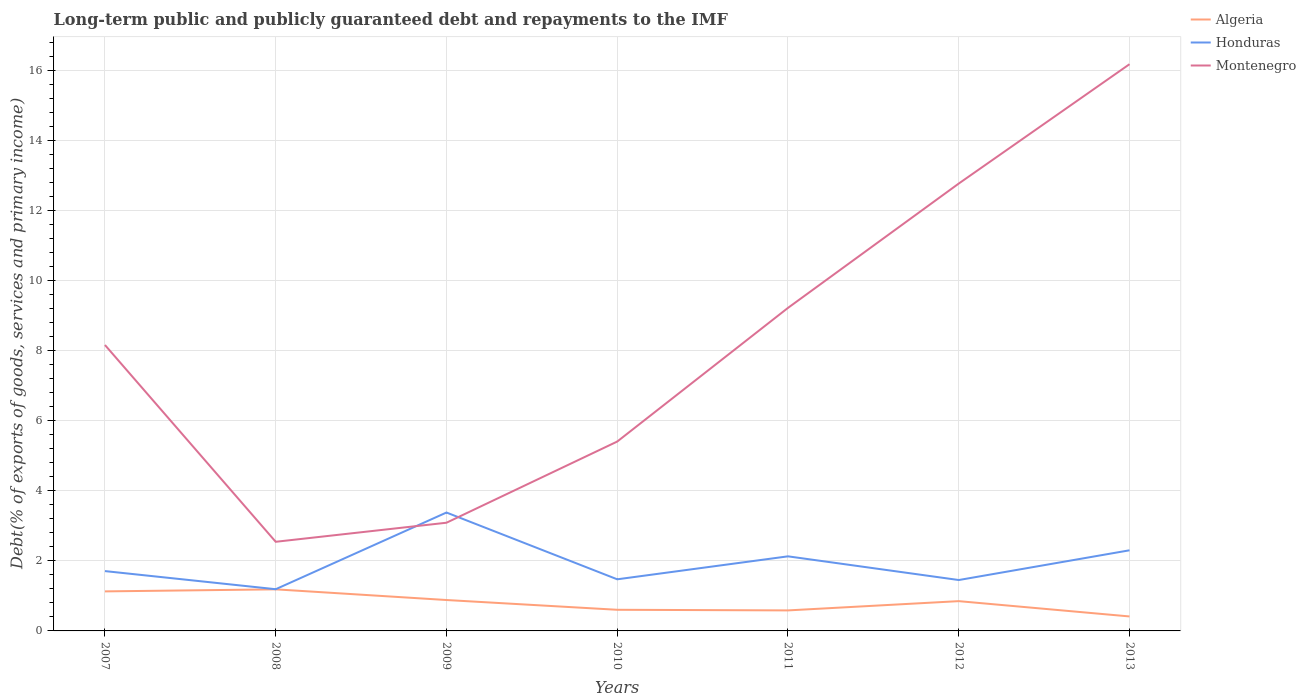Does the line corresponding to Algeria intersect with the line corresponding to Honduras?
Give a very brief answer. No. Across all years, what is the maximum debt and repayments in Honduras?
Make the answer very short. 1.19. What is the total debt and repayments in Honduras in the graph?
Give a very brief answer. -1.67. What is the difference between the highest and the second highest debt and repayments in Honduras?
Your response must be concise. 2.19. What is the difference between the highest and the lowest debt and repayments in Montenegro?
Make the answer very short. 3. Is the debt and repayments in Montenegro strictly greater than the debt and repayments in Honduras over the years?
Provide a succinct answer. No. How many years are there in the graph?
Offer a very short reply. 7. Does the graph contain any zero values?
Provide a short and direct response. No. How many legend labels are there?
Keep it short and to the point. 3. How are the legend labels stacked?
Your response must be concise. Vertical. What is the title of the graph?
Keep it short and to the point. Long-term public and publicly guaranteed debt and repayments to the IMF. Does "Namibia" appear as one of the legend labels in the graph?
Your answer should be very brief. No. What is the label or title of the Y-axis?
Provide a short and direct response. Debt(% of exports of goods, services and primary income). What is the Debt(% of exports of goods, services and primary income) in Algeria in 2007?
Your answer should be very brief. 1.13. What is the Debt(% of exports of goods, services and primary income) in Honduras in 2007?
Your answer should be very brief. 1.71. What is the Debt(% of exports of goods, services and primary income) in Montenegro in 2007?
Your answer should be compact. 8.17. What is the Debt(% of exports of goods, services and primary income) in Algeria in 2008?
Offer a very short reply. 1.19. What is the Debt(% of exports of goods, services and primary income) of Honduras in 2008?
Provide a succinct answer. 1.19. What is the Debt(% of exports of goods, services and primary income) in Montenegro in 2008?
Your answer should be compact. 2.55. What is the Debt(% of exports of goods, services and primary income) of Algeria in 2009?
Your response must be concise. 0.88. What is the Debt(% of exports of goods, services and primary income) of Honduras in 2009?
Your answer should be very brief. 3.38. What is the Debt(% of exports of goods, services and primary income) of Montenegro in 2009?
Keep it short and to the point. 3.09. What is the Debt(% of exports of goods, services and primary income) of Algeria in 2010?
Provide a succinct answer. 0.6. What is the Debt(% of exports of goods, services and primary income) of Honduras in 2010?
Give a very brief answer. 1.47. What is the Debt(% of exports of goods, services and primary income) of Montenegro in 2010?
Make the answer very short. 5.41. What is the Debt(% of exports of goods, services and primary income) of Algeria in 2011?
Provide a succinct answer. 0.59. What is the Debt(% of exports of goods, services and primary income) in Honduras in 2011?
Provide a short and direct response. 2.13. What is the Debt(% of exports of goods, services and primary income) of Montenegro in 2011?
Ensure brevity in your answer.  9.23. What is the Debt(% of exports of goods, services and primary income) of Algeria in 2012?
Make the answer very short. 0.85. What is the Debt(% of exports of goods, services and primary income) in Honduras in 2012?
Your answer should be compact. 1.45. What is the Debt(% of exports of goods, services and primary income) of Montenegro in 2012?
Provide a succinct answer. 12.78. What is the Debt(% of exports of goods, services and primary income) in Algeria in 2013?
Your answer should be very brief. 0.41. What is the Debt(% of exports of goods, services and primary income) in Honduras in 2013?
Make the answer very short. 2.3. What is the Debt(% of exports of goods, services and primary income) of Montenegro in 2013?
Provide a succinct answer. 16.19. Across all years, what is the maximum Debt(% of exports of goods, services and primary income) in Algeria?
Keep it short and to the point. 1.19. Across all years, what is the maximum Debt(% of exports of goods, services and primary income) of Honduras?
Make the answer very short. 3.38. Across all years, what is the maximum Debt(% of exports of goods, services and primary income) in Montenegro?
Your response must be concise. 16.19. Across all years, what is the minimum Debt(% of exports of goods, services and primary income) in Algeria?
Your answer should be very brief. 0.41. Across all years, what is the minimum Debt(% of exports of goods, services and primary income) of Honduras?
Ensure brevity in your answer.  1.19. Across all years, what is the minimum Debt(% of exports of goods, services and primary income) of Montenegro?
Offer a very short reply. 2.55. What is the total Debt(% of exports of goods, services and primary income) in Algeria in the graph?
Ensure brevity in your answer.  5.66. What is the total Debt(% of exports of goods, services and primary income) in Honduras in the graph?
Offer a terse response. 13.65. What is the total Debt(% of exports of goods, services and primary income) in Montenegro in the graph?
Offer a very short reply. 57.42. What is the difference between the Debt(% of exports of goods, services and primary income) of Algeria in 2007 and that in 2008?
Make the answer very short. -0.06. What is the difference between the Debt(% of exports of goods, services and primary income) in Honduras in 2007 and that in 2008?
Offer a terse response. 0.52. What is the difference between the Debt(% of exports of goods, services and primary income) of Montenegro in 2007 and that in 2008?
Provide a succinct answer. 5.62. What is the difference between the Debt(% of exports of goods, services and primary income) of Algeria in 2007 and that in 2009?
Offer a terse response. 0.25. What is the difference between the Debt(% of exports of goods, services and primary income) of Honduras in 2007 and that in 2009?
Provide a succinct answer. -1.67. What is the difference between the Debt(% of exports of goods, services and primary income) of Montenegro in 2007 and that in 2009?
Your response must be concise. 5.08. What is the difference between the Debt(% of exports of goods, services and primary income) of Algeria in 2007 and that in 2010?
Your response must be concise. 0.53. What is the difference between the Debt(% of exports of goods, services and primary income) of Honduras in 2007 and that in 2010?
Your response must be concise. 0.23. What is the difference between the Debt(% of exports of goods, services and primary income) of Montenegro in 2007 and that in 2010?
Give a very brief answer. 2.76. What is the difference between the Debt(% of exports of goods, services and primary income) of Algeria in 2007 and that in 2011?
Give a very brief answer. 0.54. What is the difference between the Debt(% of exports of goods, services and primary income) of Honduras in 2007 and that in 2011?
Make the answer very short. -0.42. What is the difference between the Debt(% of exports of goods, services and primary income) of Montenegro in 2007 and that in 2011?
Offer a very short reply. -1.06. What is the difference between the Debt(% of exports of goods, services and primary income) in Algeria in 2007 and that in 2012?
Offer a very short reply. 0.28. What is the difference between the Debt(% of exports of goods, services and primary income) of Honduras in 2007 and that in 2012?
Make the answer very short. 0.26. What is the difference between the Debt(% of exports of goods, services and primary income) in Montenegro in 2007 and that in 2012?
Your response must be concise. -4.61. What is the difference between the Debt(% of exports of goods, services and primary income) in Algeria in 2007 and that in 2013?
Offer a terse response. 0.72. What is the difference between the Debt(% of exports of goods, services and primary income) in Honduras in 2007 and that in 2013?
Your answer should be compact. -0.59. What is the difference between the Debt(% of exports of goods, services and primary income) of Montenegro in 2007 and that in 2013?
Your response must be concise. -8.02. What is the difference between the Debt(% of exports of goods, services and primary income) in Algeria in 2008 and that in 2009?
Provide a short and direct response. 0.3. What is the difference between the Debt(% of exports of goods, services and primary income) in Honduras in 2008 and that in 2009?
Ensure brevity in your answer.  -2.19. What is the difference between the Debt(% of exports of goods, services and primary income) in Montenegro in 2008 and that in 2009?
Your answer should be compact. -0.54. What is the difference between the Debt(% of exports of goods, services and primary income) in Algeria in 2008 and that in 2010?
Provide a short and direct response. 0.58. What is the difference between the Debt(% of exports of goods, services and primary income) of Honduras in 2008 and that in 2010?
Your answer should be very brief. -0.28. What is the difference between the Debt(% of exports of goods, services and primary income) in Montenegro in 2008 and that in 2010?
Your answer should be compact. -2.86. What is the difference between the Debt(% of exports of goods, services and primary income) of Algeria in 2008 and that in 2011?
Make the answer very short. 0.6. What is the difference between the Debt(% of exports of goods, services and primary income) in Honduras in 2008 and that in 2011?
Provide a short and direct response. -0.94. What is the difference between the Debt(% of exports of goods, services and primary income) in Montenegro in 2008 and that in 2011?
Give a very brief answer. -6.68. What is the difference between the Debt(% of exports of goods, services and primary income) in Algeria in 2008 and that in 2012?
Keep it short and to the point. 0.34. What is the difference between the Debt(% of exports of goods, services and primary income) of Honduras in 2008 and that in 2012?
Your response must be concise. -0.26. What is the difference between the Debt(% of exports of goods, services and primary income) of Montenegro in 2008 and that in 2012?
Keep it short and to the point. -10.24. What is the difference between the Debt(% of exports of goods, services and primary income) in Algeria in 2008 and that in 2013?
Give a very brief answer. 0.77. What is the difference between the Debt(% of exports of goods, services and primary income) in Honduras in 2008 and that in 2013?
Ensure brevity in your answer.  -1.11. What is the difference between the Debt(% of exports of goods, services and primary income) of Montenegro in 2008 and that in 2013?
Offer a terse response. -13.65. What is the difference between the Debt(% of exports of goods, services and primary income) in Algeria in 2009 and that in 2010?
Your answer should be very brief. 0.28. What is the difference between the Debt(% of exports of goods, services and primary income) in Honduras in 2009 and that in 2010?
Your answer should be compact. 1.91. What is the difference between the Debt(% of exports of goods, services and primary income) in Montenegro in 2009 and that in 2010?
Your response must be concise. -2.32. What is the difference between the Debt(% of exports of goods, services and primary income) in Algeria in 2009 and that in 2011?
Offer a very short reply. 0.3. What is the difference between the Debt(% of exports of goods, services and primary income) in Honduras in 2009 and that in 2011?
Offer a very short reply. 1.25. What is the difference between the Debt(% of exports of goods, services and primary income) in Montenegro in 2009 and that in 2011?
Your answer should be very brief. -6.14. What is the difference between the Debt(% of exports of goods, services and primary income) of Algeria in 2009 and that in 2012?
Your answer should be very brief. 0.03. What is the difference between the Debt(% of exports of goods, services and primary income) in Honduras in 2009 and that in 2012?
Ensure brevity in your answer.  1.93. What is the difference between the Debt(% of exports of goods, services and primary income) of Montenegro in 2009 and that in 2012?
Provide a succinct answer. -9.69. What is the difference between the Debt(% of exports of goods, services and primary income) in Algeria in 2009 and that in 2013?
Give a very brief answer. 0.47. What is the difference between the Debt(% of exports of goods, services and primary income) in Honduras in 2009 and that in 2013?
Make the answer very short. 1.08. What is the difference between the Debt(% of exports of goods, services and primary income) in Montenegro in 2009 and that in 2013?
Keep it short and to the point. -13.1. What is the difference between the Debt(% of exports of goods, services and primary income) of Algeria in 2010 and that in 2011?
Give a very brief answer. 0.02. What is the difference between the Debt(% of exports of goods, services and primary income) in Honduras in 2010 and that in 2011?
Keep it short and to the point. -0.66. What is the difference between the Debt(% of exports of goods, services and primary income) in Montenegro in 2010 and that in 2011?
Offer a very short reply. -3.82. What is the difference between the Debt(% of exports of goods, services and primary income) in Algeria in 2010 and that in 2012?
Keep it short and to the point. -0.25. What is the difference between the Debt(% of exports of goods, services and primary income) in Honduras in 2010 and that in 2012?
Ensure brevity in your answer.  0.02. What is the difference between the Debt(% of exports of goods, services and primary income) of Montenegro in 2010 and that in 2012?
Your answer should be very brief. -7.37. What is the difference between the Debt(% of exports of goods, services and primary income) of Algeria in 2010 and that in 2013?
Give a very brief answer. 0.19. What is the difference between the Debt(% of exports of goods, services and primary income) in Honduras in 2010 and that in 2013?
Ensure brevity in your answer.  -0.83. What is the difference between the Debt(% of exports of goods, services and primary income) of Montenegro in 2010 and that in 2013?
Offer a very short reply. -10.78. What is the difference between the Debt(% of exports of goods, services and primary income) in Algeria in 2011 and that in 2012?
Offer a very short reply. -0.26. What is the difference between the Debt(% of exports of goods, services and primary income) in Honduras in 2011 and that in 2012?
Offer a terse response. 0.68. What is the difference between the Debt(% of exports of goods, services and primary income) in Montenegro in 2011 and that in 2012?
Your answer should be very brief. -3.55. What is the difference between the Debt(% of exports of goods, services and primary income) in Algeria in 2011 and that in 2013?
Provide a succinct answer. 0.17. What is the difference between the Debt(% of exports of goods, services and primary income) in Honduras in 2011 and that in 2013?
Your response must be concise. -0.17. What is the difference between the Debt(% of exports of goods, services and primary income) in Montenegro in 2011 and that in 2013?
Provide a succinct answer. -6.96. What is the difference between the Debt(% of exports of goods, services and primary income) in Algeria in 2012 and that in 2013?
Provide a succinct answer. 0.44. What is the difference between the Debt(% of exports of goods, services and primary income) in Honduras in 2012 and that in 2013?
Offer a very short reply. -0.85. What is the difference between the Debt(% of exports of goods, services and primary income) in Montenegro in 2012 and that in 2013?
Your answer should be very brief. -3.41. What is the difference between the Debt(% of exports of goods, services and primary income) in Algeria in 2007 and the Debt(% of exports of goods, services and primary income) in Honduras in 2008?
Make the answer very short. -0.06. What is the difference between the Debt(% of exports of goods, services and primary income) in Algeria in 2007 and the Debt(% of exports of goods, services and primary income) in Montenegro in 2008?
Make the answer very short. -1.42. What is the difference between the Debt(% of exports of goods, services and primary income) in Honduras in 2007 and the Debt(% of exports of goods, services and primary income) in Montenegro in 2008?
Keep it short and to the point. -0.84. What is the difference between the Debt(% of exports of goods, services and primary income) of Algeria in 2007 and the Debt(% of exports of goods, services and primary income) of Honduras in 2009?
Provide a succinct answer. -2.25. What is the difference between the Debt(% of exports of goods, services and primary income) in Algeria in 2007 and the Debt(% of exports of goods, services and primary income) in Montenegro in 2009?
Provide a succinct answer. -1.96. What is the difference between the Debt(% of exports of goods, services and primary income) in Honduras in 2007 and the Debt(% of exports of goods, services and primary income) in Montenegro in 2009?
Your response must be concise. -1.38. What is the difference between the Debt(% of exports of goods, services and primary income) in Algeria in 2007 and the Debt(% of exports of goods, services and primary income) in Honduras in 2010?
Your response must be concise. -0.35. What is the difference between the Debt(% of exports of goods, services and primary income) of Algeria in 2007 and the Debt(% of exports of goods, services and primary income) of Montenegro in 2010?
Your answer should be very brief. -4.28. What is the difference between the Debt(% of exports of goods, services and primary income) in Honduras in 2007 and the Debt(% of exports of goods, services and primary income) in Montenegro in 2010?
Provide a short and direct response. -3.7. What is the difference between the Debt(% of exports of goods, services and primary income) in Algeria in 2007 and the Debt(% of exports of goods, services and primary income) in Honduras in 2011?
Keep it short and to the point. -1. What is the difference between the Debt(% of exports of goods, services and primary income) of Algeria in 2007 and the Debt(% of exports of goods, services and primary income) of Montenegro in 2011?
Provide a succinct answer. -8.1. What is the difference between the Debt(% of exports of goods, services and primary income) in Honduras in 2007 and the Debt(% of exports of goods, services and primary income) in Montenegro in 2011?
Offer a very short reply. -7.52. What is the difference between the Debt(% of exports of goods, services and primary income) in Algeria in 2007 and the Debt(% of exports of goods, services and primary income) in Honduras in 2012?
Provide a succinct answer. -0.32. What is the difference between the Debt(% of exports of goods, services and primary income) in Algeria in 2007 and the Debt(% of exports of goods, services and primary income) in Montenegro in 2012?
Keep it short and to the point. -11.65. What is the difference between the Debt(% of exports of goods, services and primary income) of Honduras in 2007 and the Debt(% of exports of goods, services and primary income) of Montenegro in 2012?
Provide a succinct answer. -11.07. What is the difference between the Debt(% of exports of goods, services and primary income) in Algeria in 2007 and the Debt(% of exports of goods, services and primary income) in Honduras in 2013?
Give a very brief answer. -1.17. What is the difference between the Debt(% of exports of goods, services and primary income) of Algeria in 2007 and the Debt(% of exports of goods, services and primary income) of Montenegro in 2013?
Your answer should be very brief. -15.06. What is the difference between the Debt(% of exports of goods, services and primary income) in Honduras in 2007 and the Debt(% of exports of goods, services and primary income) in Montenegro in 2013?
Your response must be concise. -14.48. What is the difference between the Debt(% of exports of goods, services and primary income) of Algeria in 2008 and the Debt(% of exports of goods, services and primary income) of Honduras in 2009?
Your response must be concise. -2.19. What is the difference between the Debt(% of exports of goods, services and primary income) in Algeria in 2008 and the Debt(% of exports of goods, services and primary income) in Montenegro in 2009?
Offer a terse response. -1.9. What is the difference between the Debt(% of exports of goods, services and primary income) of Honduras in 2008 and the Debt(% of exports of goods, services and primary income) of Montenegro in 2009?
Your response must be concise. -1.9. What is the difference between the Debt(% of exports of goods, services and primary income) in Algeria in 2008 and the Debt(% of exports of goods, services and primary income) in Honduras in 2010?
Offer a very short reply. -0.29. What is the difference between the Debt(% of exports of goods, services and primary income) in Algeria in 2008 and the Debt(% of exports of goods, services and primary income) in Montenegro in 2010?
Your response must be concise. -4.22. What is the difference between the Debt(% of exports of goods, services and primary income) of Honduras in 2008 and the Debt(% of exports of goods, services and primary income) of Montenegro in 2010?
Give a very brief answer. -4.22. What is the difference between the Debt(% of exports of goods, services and primary income) in Algeria in 2008 and the Debt(% of exports of goods, services and primary income) in Honduras in 2011?
Make the answer very short. -0.94. What is the difference between the Debt(% of exports of goods, services and primary income) of Algeria in 2008 and the Debt(% of exports of goods, services and primary income) of Montenegro in 2011?
Your response must be concise. -8.04. What is the difference between the Debt(% of exports of goods, services and primary income) in Honduras in 2008 and the Debt(% of exports of goods, services and primary income) in Montenegro in 2011?
Keep it short and to the point. -8.04. What is the difference between the Debt(% of exports of goods, services and primary income) of Algeria in 2008 and the Debt(% of exports of goods, services and primary income) of Honduras in 2012?
Provide a short and direct response. -0.27. What is the difference between the Debt(% of exports of goods, services and primary income) of Algeria in 2008 and the Debt(% of exports of goods, services and primary income) of Montenegro in 2012?
Your answer should be compact. -11.59. What is the difference between the Debt(% of exports of goods, services and primary income) in Honduras in 2008 and the Debt(% of exports of goods, services and primary income) in Montenegro in 2012?
Give a very brief answer. -11.59. What is the difference between the Debt(% of exports of goods, services and primary income) of Algeria in 2008 and the Debt(% of exports of goods, services and primary income) of Honduras in 2013?
Your answer should be compact. -1.12. What is the difference between the Debt(% of exports of goods, services and primary income) of Algeria in 2008 and the Debt(% of exports of goods, services and primary income) of Montenegro in 2013?
Keep it short and to the point. -15. What is the difference between the Debt(% of exports of goods, services and primary income) in Honduras in 2008 and the Debt(% of exports of goods, services and primary income) in Montenegro in 2013?
Offer a terse response. -15. What is the difference between the Debt(% of exports of goods, services and primary income) in Algeria in 2009 and the Debt(% of exports of goods, services and primary income) in Honduras in 2010?
Keep it short and to the point. -0.59. What is the difference between the Debt(% of exports of goods, services and primary income) of Algeria in 2009 and the Debt(% of exports of goods, services and primary income) of Montenegro in 2010?
Provide a short and direct response. -4.53. What is the difference between the Debt(% of exports of goods, services and primary income) in Honduras in 2009 and the Debt(% of exports of goods, services and primary income) in Montenegro in 2010?
Your response must be concise. -2.03. What is the difference between the Debt(% of exports of goods, services and primary income) in Algeria in 2009 and the Debt(% of exports of goods, services and primary income) in Honduras in 2011?
Your answer should be compact. -1.25. What is the difference between the Debt(% of exports of goods, services and primary income) in Algeria in 2009 and the Debt(% of exports of goods, services and primary income) in Montenegro in 2011?
Offer a terse response. -8.35. What is the difference between the Debt(% of exports of goods, services and primary income) of Honduras in 2009 and the Debt(% of exports of goods, services and primary income) of Montenegro in 2011?
Provide a succinct answer. -5.85. What is the difference between the Debt(% of exports of goods, services and primary income) in Algeria in 2009 and the Debt(% of exports of goods, services and primary income) in Honduras in 2012?
Offer a terse response. -0.57. What is the difference between the Debt(% of exports of goods, services and primary income) in Algeria in 2009 and the Debt(% of exports of goods, services and primary income) in Montenegro in 2012?
Ensure brevity in your answer.  -11.9. What is the difference between the Debt(% of exports of goods, services and primary income) in Honduras in 2009 and the Debt(% of exports of goods, services and primary income) in Montenegro in 2012?
Your answer should be compact. -9.4. What is the difference between the Debt(% of exports of goods, services and primary income) in Algeria in 2009 and the Debt(% of exports of goods, services and primary income) in Honduras in 2013?
Offer a very short reply. -1.42. What is the difference between the Debt(% of exports of goods, services and primary income) in Algeria in 2009 and the Debt(% of exports of goods, services and primary income) in Montenegro in 2013?
Make the answer very short. -15.31. What is the difference between the Debt(% of exports of goods, services and primary income) in Honduras in 2009 and the Debt(% of exports of goods, services and primary income) in Montenegro in 2013?
Your response must be concise. -12.81. What is the difference between the Debt(% of exports of goods, services and primary income) of Algeria in 2010 and the Debt(% of exports of goods, services and primary income) of Honduras in 2011?
Provide a short and direct response. -1.53. What is the difference between the Debt(% of exports of goods, services and primary income) in Algeria in 2010 and the Debt(% of exports of goods, services and primary income) in Montenegro in 2011?
Keep it short and to the point. -8.63. What is the difference between the Debt(% of exports of goods, services and primary income) of Honduras in 2010 and the Debt(% of exports of goods, services and primary income) of Montenegro in 2011?
Your response must be concise. -7.75. What is the difference between the Debt(% of exports of goods, services and primary income) of Algeria in 2010 and the Debt(% of exports of goods, services and primary income) of Honduras in 2012?
Offer a terse response. -0.85. What is the difference between the Debt(% of exports of goods, services and primary income) in Algeria in 2010 and the Debt(% of exports of goods, services and primary income) in Montenegro in 2012?
Offer a very short reply. -12.18. What is the difference between the Debt(% of exports of goods, services and primary income) of Honduras in 2010 and the Debt(% of exports of goods, services and primary income) of Montenegro in 2012?
Your answer should be very brief. -11.31. What is the difference between the Debt(% of exports of goods, services and primary income) in Algeria in 2010 and the Debt(% of exports of goods, services and primary income) in Honduras in 2013?
Keep it short and to the point. -1.7. What is the difference between the Debt(% of exports of goods, services and primary income) in Algeria in 2010 and the Debt(% of exports of goods, services and primary income) in Montenegro in 2013?
Offer a terse response. -15.59. What is the difference between the Debt(% of exports of goods, services and primary income) of Honduras in 2010 and the Debt(% of exports of goods, services and primary income) of Montenegro in 2013?
Provide a short and direct response. -14.72. What is the difference between the Debt(% of exports of goods, services and primary income) of Algeria in 2011 and the Debt(% of exports of goods, services and primary income) of Honduras in 2012?
Your response must be concise. -0.87. What is the difference between the Debt(% of exports of goods, services and primary income) of Algeria in 2011 and the Debt(% of exports of goods, services and primary income) of Montenegro in 2012?
Offer a terse response. -12.2. What is the difference between the Debt(% of exports of goods, services and primary income) in Honduras in 2011 and the Debt(% of exports of goods, services and primary income) in Montenegro in 2012?
Provide a succinct answer. -10.65. What is the difference between the Debt(% of exports of goods, services and primary income) in Algeria in 2011 and the Debt(% of exports of goods, services and primary income) in Honduras in 2013?
Your answer should be very brief. -1.72. What is the difference between the Debt(% of exports of goods, services and primary income) in Algeria in 2011 and the Debt(% of exports of goods, services and primary income) in Montenegro in 2013?
Provide a short and direct response. -15.61. What is the difference between the Debt(% of exports of goods, services and primary income) in Honduras in 2011 and the Debt(% of exports of goods, services and primary income) in Montenegro in 2013?
Your answer should be very brief. -14.06. What is the difference between the Debt(% of exports of goods, services and primary income) in Algeria in 2012 and the Debt(% of exports of goods, services and primary income) in Honduras in 2013?
Your response must be concise. -1.45. What is the difference between the Debt(% of exports of goods, services and primary income) of Algeria in 2012 and the Debt(% of exports of goods, services and primary income) of Montenegro in 2013?
Offer a terse response. -15.34. What is the difference between the Debt(% of exports of goods, services and primary income) in Honduras in 2012 and the Debt(% of exports of goods, services and primary income) in Montenegro in 2013?
Ensure brevity in your answer.  -14.74. What is the average Debt(% of exports of goods, services and primary income) of Algeria per year?
Offer a very short reply. 0.81. What is the average Debt(% of exports of goods, services and primary income) in Honduras per year?
Your answer should be very brief. 1.95. What is the average Debt(% of exports of goods, services and primary income) in Montenegro per year?
Ensure brevity in your answer.  8.2. In the year 2007, what is the difference between the Debt(% of exports of goods, services and primary income) in Algeria and Debt(% of exports of goods, services and primary income) in Honduras?
Ensure brevity in your answer.  -0.58. In the year 2007, what is the difference between the Debt(% of exports of goods, services and primary income) in Algeria and Debt(% of exports of goods, services and primary income) in Montenegro?
Offer a very short reply. -7.04. In the year 2007, what is the difference between the Debt(% of exports of goods, services and primary income) in Honduras and Debt(% of exports of goods, services and primary income) in Montenegro?
Ensure brevity in your answer.  -6.46. In the year 2008, what is the difference between the Debt(% of exports of goods, services and primary income) in Algeria and Debt(% of exports of goods, services and primary income) in Honduras?
Your answer should be compact. -0. In the year 2008, what is the difference between the Debt(% of exports of goods, services and primary income) of Algeria and Debt(% of exports of goods, services and primary income) of Montenegro?
Ensure brevity in your answer.  -1.36. In the year 2008, what is the difference between the Debt(% of exports of goods, services and primary income) of Honduras and Debt(% of exports of goods, services and primary income) of Montenegro?
Your answer should be very brief. -1.36. In the year 2009, what is the difference between the Debt(% of exports of goods, services and primary income) in Algeria and Debt(% of exports of goods, services and primary income) in Honduras?
Provide a short and direct response. -2.5. In the year 2009, what is the difference between the Debt(% of exports of goods, services and primary income) in Algeria and Debt(% of exports of goods, services and primary income) in Montenegro?
Your response must be concise. -2.21. In the year 2009, what is the difference between the Debt(% of exports of goods, services and primary income) in Honduras and Debt(% of exports of goods, services and primary income) in Montenegro?
Keep it short and to the point. 0.29. In the year 2010, what is the difference between the Debt(% of exports of goods, services and primary income) in Algeria and Debt(% of exports of goods, services and primary income) in Honduras?
Keep it short and to the point. -0.87. In the year 2010, what is the difference between the Debt(% of exports of goods, services and primary income) in Algeria and Debt(% of exports of goods, services and primary income) in Montenegro?
Give a very brief answer. -4.81. In the year 2010, what is the difference between the Debt(% of exports of goods, services and primary income) in Honduras and Debt(% of exports of goods, services and primary income) in Montenegro?
Provide a short and direct response. -3.94. In the year 2011, what is the difference between the Debt(% of exports of goods, services and primary income) of Algeria and Debt(% of exports of goods, services and primary income) of Honduras?
Offer a terse response. -1.54. In the year 2011, what is the difference between the Debt(% of exports of goods, services and primary income) in Algeria and Debt(% of exports of goods, services and primary income) in Montenegro?
Keep it short and to the point. -8.64. In the year 2011, what is the difference between the Debt(% of exports of goods, services and primary income) in Honduras and Debt(% of exports of goods, services and primary income) in Montenegro?
Your answer should be compact. -7.1. In the year 2012, what is the difference between the Debt(% of exports of goods, services and primary income) of Algeria and Debt(% of exports of goods, services and primary income) of Honduras?
Make the answer very short. -0.6. In the year 2012, what is the difference between the Debt(% of exports of goods, services and primary income) in Algeria and Debt(% of exports of goods, services and primary income) in Montenegro?
Offer a terse response. -11.93. In the year 2012, what is the difference between the Debt(% of exports of goods, services and primary income) of Honduras and Debt(% of exports of goods, services and primary income) of Montenegro?
Your response must be concise. -11.33. In the year 2013, what is the difference between the Debt(% of exports of goods, services and primary income) in Algeria and Debt(% of exports of goods, services and primary income) in Honduras?
Provide a succinct answer. -1.89. In the year 2013, what is the difference between the Debt(% of exports of goods, services and primary income) in Algeria and Debt(% of exports of goods, services and primary income) in Montenegro?
Your answer should be very brief. -15.78. In the year 2013, what is the difference between the Debt(% of exports of goods, services and primary income) in Honduras and Debt(% of exports of goods, services and primary income) in Montenegro?
Offer a terse response. -13.89. What is the ratio of the Debt(% of exports of goods, services and primary income) of Algeria in 2007 to that in 2008?
Keep it short and to the point. 0.95. What is the ratio of the Debt(% of exports of goods, services and primary income) in Honduras in 2007 to that in 2008?
Your answer should be very brief. 1.43. What is the ratio of the Debt(% of exports of goods, services and primary income) of Montenegro in 2007 to that in 2008?
Offer a very short reply. 3.21. What is the ratio of the Debt(% of exports of goods, services and primary income) in Algeria in 2007 to that in 2009?
Make the answer very short. 1.28. What is the ratio of the Debt(% of exports of goods, services and primary income) of Honduras in 2007 to that in 2009?
Give a very brief answer. 0.51. What is the ratio of the Debt(% of exports of goods, services and primary income) of Montenegro in 2007 to that in 2009?
Your answer should be very brief. 2.64. What is the ratio of the Debt(% of exports of goods, services and primary income) of Algeria in 2007 to that in 2010?
Keep it short and to the point. 1.87. What is the ratio of the Debt(% of exports of goods, services and primary income) in Honduras in 2007 to that in 2010?
Ensure brevity in your answer.  1.16. What is the ratio of the Debt(% of exports of goods, services and primary income) in Montenegro in 2007 to that in 2010?
Give a very brief answer. 1.51. What is the ratio of the Debt(% of exports of goods, services and primary income) of Algeria in 2007 to that in 2011?
Keep it short and to the point. 1.93. What is the ratio of the Debt(% of exports of goods, services and primary income) in Honduras in 2007 to that in 2011?
Make the answer very short. 0.8. What is the ratio of the Debt(% of exports of goods, services and primary income) in Montenegro in 2007 to that in 2011?
Offer a terse response. 0.89. What is the ratio of the Debt(% of exports of goods, services and primary income) of Algeria in 2007 to that in 2012?
Your response must be concise. 1.33. What is the ratio of the Debt(% of exports of goods, services and primary income) of Honduras in 2007 to that in 2012?
Provide a succinct answer. 1.18. What is the ratio of the Debt(% of exports of goods, services and primary income) in Montenegro in 2007 to that in 2012?
Your answer should be very brief. 0.64. What is the ratio of the Debt(% of exports of goods, services and primary income) in Algeria in 2007 to that in 2013?
Offer a terse response. 2.73. What is the ratio of the Debt(% of exports of goods, services and primary income) in Honduras in 2007 to that in 2013?
Provide a succinct answer. 0.74. What is the ratio of the Debt(% of exports of goods, services and primary income) of Montenegro in 2007 to that in 2013?
Provide a short and direct response. 0.5. What is the ratio of the Debt(% of exports of goods, services and primary income) in Algeria in 2008 to that in 2009?
Offer a terse response. 1.35. What is the ratio of the Debt(% of exports of goods, services and primary income) in Honduras in 2008 to that in 2009?
Give a very brief answer. 0.35. What is the ratio of the Debt(% of exports of goods, services and primary income) of Montenegro in 2008 to that in 2009?
Provide a short and direct response. 0.82. What is the ratio of the Debt(% of exports of goods, services and primary income) of Algeria in 2008 to that in 2010?
Ensure brevity in your answer.  1.97. What is the ratio of the Debt(% of exports of goods, services and primary income) in Honduras in 2008 to that in 2010?
Ensure brevity in your answer.  0.81. What is the ratio of the Debt(% of exports of goods, services and primary income) of Montenegro in 2008 to that in 2010?
Ensure brevity in your answer.  0.47. What is the ratio of the Debt(% of exports of goods, services and primary income) of Algeria in 2008 to that in 2011?
Give a very brief answer. 2.03. What is the ratio of the Debt(% of exports of goods, services and primary income) of Honduras in 2008 to that in 2011?
Provide a short and direct response. 0.56. What is the ratio of the Debt(% of exports of goods, services and primary income) of Montenegro in 2008 to that in 2011?
Keep it short and to the point. 0.28. What is the ratio of the Debt(% of exports of goods, services and primary income) of Algeria in 2008 to that in 2012?
Provide a succinct answer. 1.4. What is the ratio of the Debt(% of exports of goods, services and primary income) of Honduras in 2008 to that in 2012?
Give a very brief answer. 0.82. What is the ratio of the Debt(% of exports of goods, services and primary income) in Montenegro in 2008 to that in 2012?
Provide a short and direct response. 0.2. What is the ratio of the Debt(% of exports of goods, services and primary income) of Algeria in 2008 to that in 2013?
Your answer should be very brief. 2.87. What is the ratio of the Debt(% of exports of goods, services and primary income) of Honduras in 2008 to that in 2013?
Offer a terse response. 0.52. What is the ratio of the Debt(% of exports of goods, services and primary income) of Montenegro in 2008 to that in 2013?
Keep it short and to the point. 0.16. What is the ratio of the Debt(% of exports of goods, services and primary income) in Algeria in 2009 to that in 2010?
Ensure brevity in your answer.  1.46. What is the ratio of the Debt(% of exports of goods, services and primary income) in Honduras in 2009 to that in 2010?
Offer a terse response. 2.29. What is the ratio of the Debt(% of exports of goods, services and primary income) in Montenegro in 2009 to that in 2010?
Make the answer very short. 0.57. What is the ratio of the Debt(% of exports of goods, services and primary income) of Algeria in 2009 to that in 2011?
Your response must be concise. 1.51. What is the ratio of the Debt(% of exports of goods, services and primary income) in Honduras in 2009 to that in 2011?
Your answer should be compact. 1.59. What is the ratio of the Debt(% of exports of goods, services and primary income) of Montenegro in 2009 to that in 2011?
Provide a short and direct response. 0.33. What is the ratio of the Debt(% of exports of goods, services and primary income) in Algeria in 2009 to that in 2012?
Your answer should be compact. 1.04. What is the ratio of the Debt(% of exports of goods, services and primary income) of Honduras in 2009 to that in 2012?
Ensure brevity in your answer.  2.33. What is the ratio of the Debt(% of exports of goods, services and primary income) in Montenegro in 2009 to that in 2012?
Provide a short and direct response. 0.24. What is the ratio of the Debt(% of exports of goods, services and primary income) of Algeria in 2009 to that in 2013?
Make the answer very short. 2.14. What is the ratio of the Debt(% of exports of goods, services and primary income) of Honduras in 2009 to that in 2013?
Offer a very short reply. 1.47. What is the ratio of the Debt(% of exports of goods, services and primary income) of Montenegro in 2009 to that in 2013?
Give a very brief answer. 0.19. What is the ratio of the Debt(% of exports of goods, services and primary income) in Algeria in 2010 to that in 2011?
Keep it short and to the point. 1.03. What is the ratio of the Debt(% of exports of goods, services and primary income) of Honduras in 2010 to that in 2011?
Make the answer very short. 0.69. What is the ratio of the Debt(% of exports of goods, services and primary income) in Montenegro in 2010 to that in 2011?
Your answer should be very brief. 0.59. What is the ratio of the Debt(% of exports of goods, services and primary income) of Algeria in 2010 to that in 2012?
Provide a short and direct response. 0.71. What is the ratio of the Debt(% of exports of goods, services and primary income) in Honduras in 2010 to that in 2012?
Your answer should be compact. 1.01. What is the ratio of the Debt(% of exports of goods, services and primary income) of Montenegro in 2010 to that in 2012?
Your answer should be very brief. 0.42. What is the ratio of the Debt(% of exports of goods, services and primary income) of Algeria in 2010 to that in 2013?
Make the answer very short. 1.46. What is the ratio of the Debt(% of exports of goods, services and primary income) in Honduras in 2010 to that in 2013?
Your answer should be compact. 0.64. What is the ratio of the Debt(% of exports of goods, services and primary income) in Montenegro in 2010 to that in 2013?
Provide a succinct answer. 0.33. What is the ratio of the Debt(% of exports of goods, services and primary income) in Algeria in 2011 to that in 2012?
Provide a succinct answer. 0.69. What is the ratio of the Debt(% of exports of goods, services and primary income) in Honduras in 2011 to that in 2012?
Keep it short and to the point. 1.47. What is the ratio of the Debt(% of exports of goods, services and primary income) of Montenegro in 2011 to that in 2012?
Provide a succinct answer. 0.72. What is the ratio of the Debt(% of exports of goods, services and primary income) of Algeria in 2011 to that in 2013?
Provide a succinct answer. 1.42. What is the ratio of the Debt(% of exports of goods, services and primary income) of Honduras in 2011 to that in 2013?
Keep it short and to the point. 0.93. What is the ratio of the Debt(% of exports of goods, services and primary income) in Montenegro in 2011 to that in 2013?
Make the answer very short. 0.57. What is the ratio of the Debt(% of exports of goods, services and primary income) in Algeria in 2012 to that in 2013?
Your response must be concise. 2.06. What is the ratio of the Debt(% of exports of goods, services and primary income) in Honduras in 2012 to that in 2013?
Your answer should be compact. 0.63. What is the ratio of the Debt(% of exports of goods, services and primary income) in Montenegro in 2012 to that in 2013?
Provide a short and direct response. 0.79. What is the difference between the highest and the second highest Debt(% of exports of goods, services and primary income) in Algeria?
Give a very brief answer. 0.06. What is the difference between the highest and the second highest Debt(% of exports of goods, services and primary income) of Honduras?
Offer a terse response. 1.08. What is the difference between the highest and the second highest Debt(% of exports of goods, services and primary income) in Montenegro?
Provide a succinct answer. 3.41. What is the difference between the highest and the lowest Debt(% of exports of goods, services and primary income) of Algeria?
Provide a short and direct response. 0.77. What is the difference between the highest and the lowest Debt(% of exports of goods, services and primary income) in Honduras?
Your answer should be very brief. 2.19. What is the difference between the highest and the lowest Debt(% of exports of goods, services and primary income) in Montenegro?
Provide a succinct answer. 13.65. 